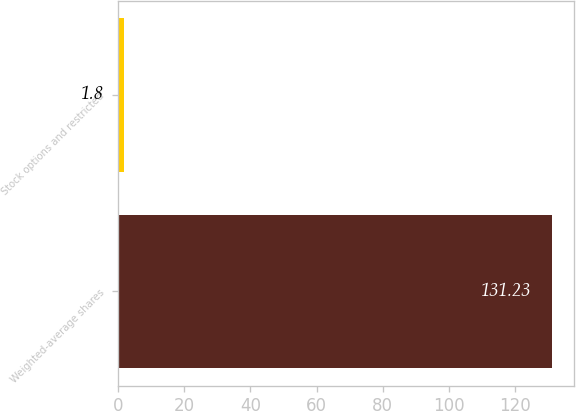Convert chart. <chart><loc_0><loc_0><loc_500><loc_500><bar_chart><fcel>Weighted-average shares<fcel>Stock options and restricted<nl><fcel>131.23<fcel>1.8<nl></chart> 